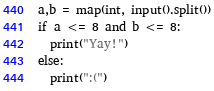<code> <loc_0><loc_0><loc_500><loc_500><_Python_>a,b = map(int, input().split())
if a <= 8 and b <= 8:
  print("Yay!")
else:
  print(":(")</code> 